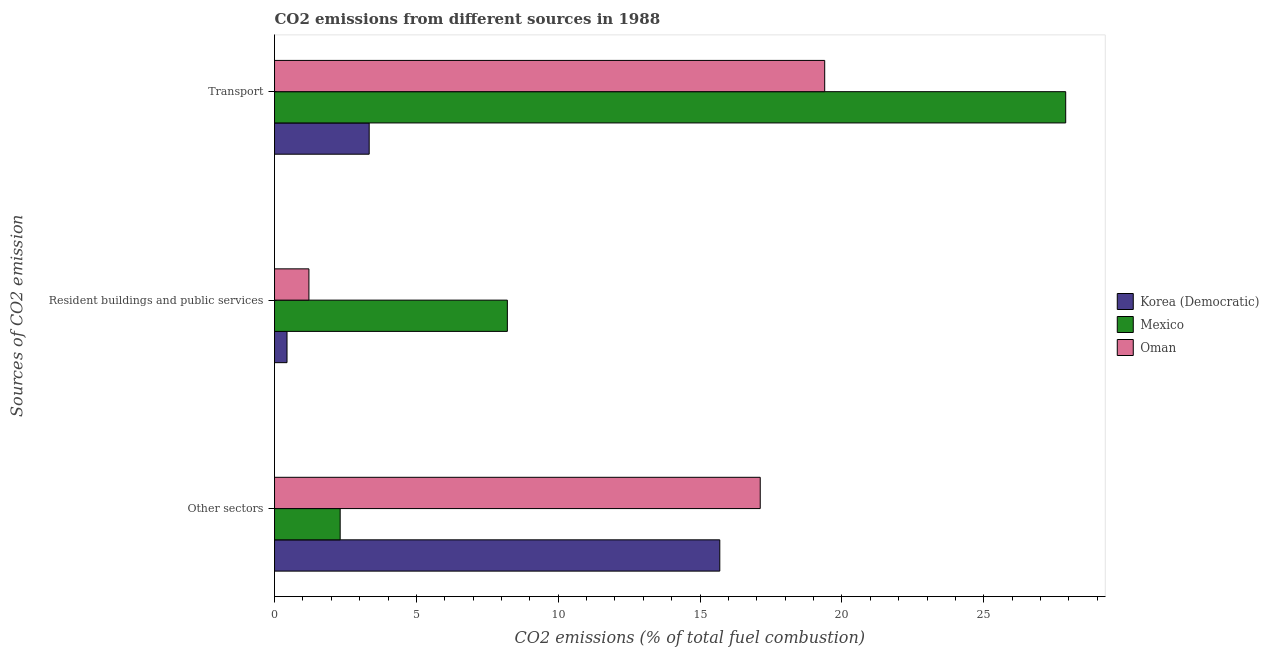How many different coloured bars are there?
Give a very brief answer. 3. How many groups of bars are there?
Offer a terse response. 3. Are the number of bars per tick equal to the number of legend labels?
Give a very brief answer. Yes. Are the number of bars on each tick of the Y-axis equal?
Your response must be concise. Yes. How many bars are there on the 1st tick from the top?
Make the answer very short. 3. What is the label of the 2nd group of bars from the top?
Make the answer very short. Resident buildings and public services. What is the percentage of co2 emissions from other sectors in Oman?
Offer a very short reply. 17.12. Across all countries, what is the maximum percentage of co2 emissions from resident buildings and public services?
Your response must be concise. 8.21. Across all countries, what is the minimum percentage of co2 emissions from resident buildings and public services?
Keep it short and to the point. 0.44. What is the total percentage of co2 emissions from transport in the graph?
Your answer should be very brief. 50.62. What is the difference between the percentage of co2 emissions from resident buildings and public services in Mexico and that in Korea (Democratic)?
Offer a very short reply. 7.77. What is the difference between the percentage of co2 emissions from other sectors in Korea (Democratic) and the percentage of co2 emissions from transport in Oman?
Your response must be concise. -3.7. What is the average percentage of co2 emissions from other sectors per country?
Give a very brief answer. 11.71. What is the difference between the percentage of co2 emissions from resident buildings and public services and percentage of co2 emissions from transport in Korea (Democratic)?
Provide a succinct answer. -2.9. What is the ratio of the percentage of co2 emissions from resident buildings and public services in Korea (Democratic) to that in Mexico?
Keep it short and to the point. 0.05. Is the difference between the percentage of co2 emissions from transport in Oman and Mexico greater than the difference between the percentage of co2 emissions from resident buildings and public services in Oman and Mexico?
Your response must be concise. No. What is the difference between the highest and the second highest percentage of co2 emissions from other sectors?
Your response must be concise. 1.43. What is the difference between the highest and the lowest percentage of co2 emissions from transport?
Your answer should be very brief. 24.55. Is it the case that in every country, the sum of the percentage of co2 emissions from other sectors and percentage of co2 emissions from resident buildings and public services is greater than the percentage of co2 emissions from transport?
Ensure brevity in your answer.  No. How many bars are there?
Ensure brevity in your answer.  9. Are all the bars in the graph horizontal?
Your answer should be compact. Yes. What is the difference between two consecutive major ticks on the X-axis?
Your response must be concise. 5. Are the values on the major ticks of X-axis written in scientific E-notation?
Your answer should be very brief. No. Does the graph contain grids?
Provide a short and direct response. No. How many legend labels are there?
Provide a succinct answer. 3. What is the title of the graph?
Your answer should be compact. CO2 emissions from different sources in 1988. What is the label or title of the X-axis?
Offer a very short reply. CO2 emissions (% of total fuel combustion). What is the label or title of the Y-axis?
Ensure brevity in your answer.  Sources of CO2 emission. What is the CO2 emissions (% of total fuel combustion) of Korea (Democratic) in Other sectors?
Offer a very short reply. 15.7. What is the CO2 emissions (% of total fuel combustion) in Mexico in Other sectors?
Your answer should be very brief. 2.31. What is the CO2 emissions (% of total fuel combustion) of Oman in Other sectors?
Make the answer very short. 17.12. What is the CO2 emissions (% of total fuel combustion) in Korea (Democratic) in Resident buildings and public services?
Offer a terse response. 0.44. What is the CO2 emissions (% of total fuel combustion) in Mexico in Resident buildings and public services?
Make the answer very short. 8.21. What is the CO2 emissions (% of total fuel combustion) in Oman in Resident buildings and public services?
Your answer should be very brief. 1.21. What is the CO2 emissions (% of total fuel combustion) in Korea (Democratic) in Transport?
Provide a succinct answer. 3.34. What is the CO2 emissions (% of total fuel combustion) of Mexico in Transport?
Your answer should be very brief. 27.89. What is the CO2 emissions (% of total fuel combustion) of Oman in Transport?
Offer a very short reply. 19.39. Across all Sources of CO2 emission, what is the maximum CO2 emissions (% of total fuel combustion) of Korea (Democratic)?
Ensure brevity in your answer.  15.7. Across all Sources of CO2 emission, what is the maximum CO2 emissions (% of total fuel combustion) of Mexico?
Offer a very short reply. 27.89. Across all Sources of CO2 emission, what is the maximum CO2 emissions (% of total fuel combustion) in Oman?
Provide a succinct answer. 19.39. Across all Sources of CO2 emission, what is the minimum CO2 emissions (% of total fuel combustion) in Korea (Democratic)?
Your answer should be very brief. 0.44. Across all Sources of CO2 emission, what is the minimum CO2 emissions (% of total fuel combustion) of Mexico?
Your response must be concise. 2.31. Across all Sources of CO2 emission, what is the minimum CO2 emissions (% of total fuel combustion) of Oman?
Give a very brief answer. 1.21. What is the total CO2 emissions (% of total fuel combustion) in Korea (Democratic) in the graph?
Keep it short and to the point. 19.47. What is the total CO2 emissions (% of total fuel combustion) in Mexico in the graph?
Make the answer very short. 38.41. What is the total CO2 emissions (% of total fuel combustion) in Oman in the graph?
Your answer should be very brief. 37.73. What is the difference between the CO2 emissions (% of total fuel combustion) in Korea (Democratic) in Other sectors and that in Resident buildings and public services?
Provide a short and direct response. 15.26. What is the difference between the CO2 emissions (% of total fuel combustion) of Mexico in Other sectors and that in Resident buildings and public services?
Offer a very short reply. -5.89. What is the difference between the CO2 emissions (% of total fuel combustion) of Oman in Other sectors and that in Resident buildings and public services?
Provide a succinct answer. 15.91. What is the difference between the CO2 emissions (% of total fuel combustion) in Korea (Democratic) in Other sectors and that in Transport?
Your response must be concise. 12.36. What is the difference between the CO2 emissions (% of total fuel combustion) in Mexico in Other sectors and that in Transport?
Offer a terse response. -25.57. What is the difference between the CO2 emissions (% of total fuel combustion) in Oman in Other sectors and that in Transport?
Give a very brief answer. -2.27. What is the difference between the CO2 emissions (% of total fuel combustion) of Korea (Democratic) in Resident buildings and public services and that in Transport?
Give a very brief answer. -2.9. What is the difference between the CO2 emissions (% of total fuel combustion) of Mexico in Resident buildings and public services and that in Transport?
Offer a terse response. -19.68. What is the difference between the CO2 emissions (% of total fuel combustion) of Oman in Resident buildings and public services and that in Transport?
Provide a short and direct response. -18.18. What is the difference between the CO2 emissions (% of total fuel combustion) in Korea (Democratic) in Other sectors and the CO2 emissions (% of total fuel combustion) in Mexico in Resident buildings and public services?
Give a very brief answer. 7.49. What is the difference between the CO2 emissions (% of total fuel combustion) in Korea (Democratic) in Other sectors and the CO2 emissions (% of total fuel combustion) in Oman in Resident buildings and public services?
Give a very brief answer. 14.48. What is the difference between the CO2 emissions (% of total fuel combustion) in Mexico in Other sectors and the CO2 emissions (% of total fuel combustion) in Oman in Resident buildings and public services?
Give a very brief answer. 1.1. What is the difference between the CO2 emissions (% of total fuel combustion) in Korea (Democratic) in Other sectors and the CO2 emissions (% of total fuel combustion) in Mexico in Transport?
Give a very brief answer. -12.19. What is the difference between the CO2 emissions (% of total fuel combustion) of Korea (Democratic) in Other sectors and the CO2 emissions (% of total fuel combustion) of Oman in Transport?
Make the answer very short. -3.7. What is the difference between the CO2 emissions (% of total fuel combustion) of Mexico in Other sectors and the CO2 emissions (% of total fuel combustion) of Oman in Transport?
Make the answer very short. -17.08. What is the difference between the CO2 emissions (% of total fuel combustion) of Korea (Democratic) in Resident buildings and public services and the CO2 emissions (% of total fuel combustion) of Mexico in Transport?
Offer a terse response. -27.45. What is the difference between the CO2 emissions (% of total fuel combustion) in Korea (Democratic) in Resident buildings and public services and the CO2 emissions (% of total fuel combustion) in Oman in Transport?
Your response must be concise. -18.95. What is the difference between the CO2 emissions (% of total fuel combustion) of Mexico in Resident buildings and public services and the CO2 emissions (% of total fuel combustion) of Oman in Transport?
Your answer should be very brief. -11.19. What is the average CO2 emissions (% of total fuel combustion) of Korea (Democratic) per Sources of CO2 emission?
Offer a terse response. 6.49. What is the average CO2 emissions (% of total fuel combustion) in Mexico per Sources of CO2 emission?
Offer a very short reply. 12.8. What is the average CO2 emissions (% of total fuel combustion) of Oman per Sources of CO2 emission?
Make the answer very short. 12.58. What is the difference between the CO2 emissions (% of total fuel combustion) of Korea (Democratic) and CO2 emissions (% of total fuel combustion) of Mexico in Other sectors?
Give a very brief answer. 13.38. What is the difference between the CO2 emissions (% of total fuel combustion) of Korea (Democratic) and CO2 emissions (% of total fuel combustion) of Oman in Other sectors?
Your answer should be very brief. -1.43. What is the difference between the CO2 emissions (% of total fuel combustion) in Mexico and CO2 emissions (% of total fuel combustion) in Oman in Other sectors?
Your response must be concise. -14.81. What is the difference between the CO2 emissions (% of total fuel combustion) of Korea (Democratic) and CO2 emissions (% of total fuel combustion) of Mexico in Resident buildings and public services?
Your answer should be very brief. -7.77. What is the difference between the CO2 emissions (% of total fuel combustion) of Korea (Democratic) and CO2 emissions (% of total fuel combustion) of Oman in Resident buildings and public services?
Give a very brief answer. -0.77. What is the difference between the CO2 emissions (% of total fuel combustion) in Mexico and CO2 emissions (% of total fuel combustion) in Oman in Resident buildings and public services?
Provide a short and direct response. 7. What is the difference between the CO2 emissions (% of total fuel combustion) of Korea (Democratic) and CO2 emissions (% of total fuel combustion) of Mexico in Transport?
Your answer should be very brief. -24.55. What is the difference between the CO2 emissions (% of total fuel combustion) in Korea (Democratic) and CO2 emissions (% of total fuel combustion) in Oman in Transport?
Offer a very short reply. -16.06. What is the difference between the CO2 emissions (% of total fuel combustion) of Mexico and CO2 emissions (% of total fuel combustion) of Oman in Transport?
Provide a short and direct response. 8.49. What is the ratio of the CO2 emissions (% of total fuel combustion) in Korea (Democratic) in Other sectors to that in Resident buildings and public services?
Give a very brief answer. 35.68. What is the ratio of the CO2 emissions (% of total fuel combustion) of Mexico in Other sectors to that in Resident buildings and public services?
Your answer should be very brief. 0.28. What is the ratio of the CO2 emissions (% of total fuel combustion) in Oman in Other sectors to that in Resident buildings and public services?
Provide a short and direct response. 14.12. What is the ratio of the CO2 emissions (% of total fuel combustion) in Korea (Democratic) in Other sectors to that in Transport?
Your response must be concise. 4.7. What is the ratio of the CO2 emissions (% of total fuel combustion) in Mexico in Other sectors to that in Transport?
Your answer should be compact. 0.08. What is the ratio of the CO2 emissions (% of total fuel combustion) of Oman in Other sectors to that in Transport?
Your answer should be very brief. 0.88. What is the ratio of the CO2 emissions (% of total fuel combustion) of Korea (Democratic) in Resident buildings and public services to that in Transport?
Provide a succinct answer. 0.13. What is the ratio of the CO2 emissions (% of total fuel combustion) in Mexico in Resident buildings and public services to that in Transport?
Offer a very short reply. 0.29. What is the ratio of the CO2 emissions (% of total fuel combustion) of Oman in Resident buildings and public services to that in Transport?
Your response must be concise. 0.06. What is the difference between the highest and the second highest CO2 emissions (% of total fuel combustion) in Korea (Democratic)?
Ensure brevity in your answer.  12.36. What is the difference between the highest and the second highest CO2 emissions (% of total fuel combustion) in Mexico?
Your answer should be very brief. 19.68. What is the difference between the highest and the second highest CO2 emissions (% of total fuel combustion) in Oman?
Provide a short and direct response. 2.27. What is the difference between the highest and the lowest CO2 emissions (% of total fuel combustion) in Korea (Democratic)?
Provide a succinct answer. 15.26. What is the difference between the highest and the lowest CO2 emissions (% of total fuel combustion) of Mexico?
Provide a succinct answer. 25.57. What is the difference between the highest and the lowest CO2 emissions (% of total fuel combustion) in Oman?
Offer a very short reply. 18.18. 